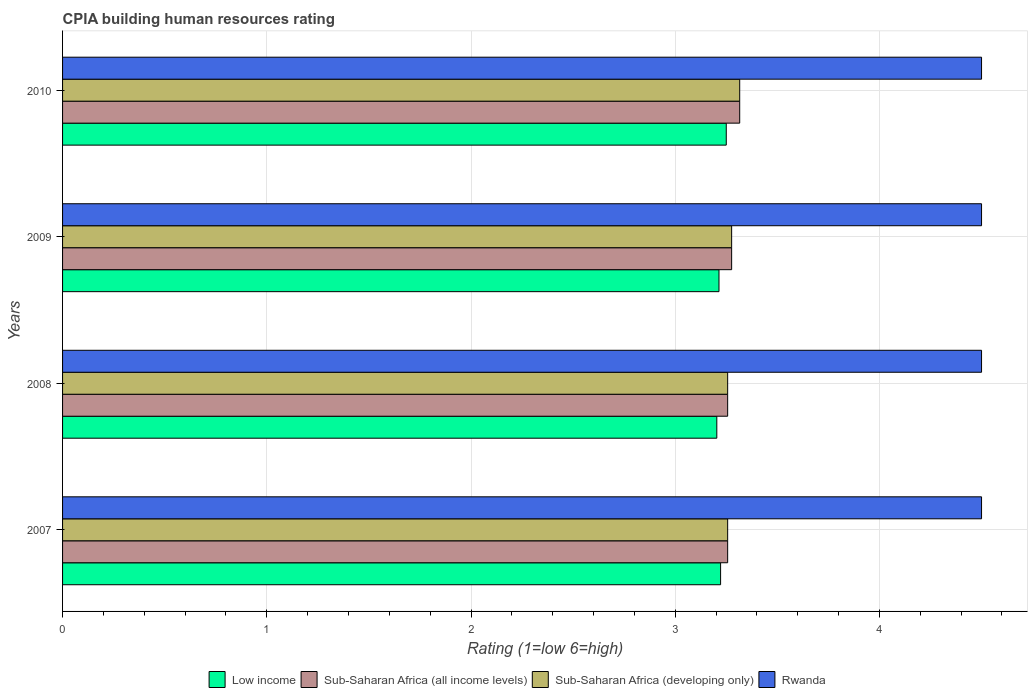How many different coloured bars are there?
Give a very brief answer. 4. How many groups of bars are there?
Offer a terse response. 4. Are the number of bars per tick equal to the number of legend labels?
Keep it short and to the point. Yes. Are the number of bars on each tick of the Y-axis equal?
Keep it short and to the point. Yes. How many bars are there on the 4th tick from the top?
Provide a succinct answer. 4. What is the CPIA rating in Sub-Saharan Africa (all income levels) in 2010?
Offer a very short reply. 3.32. Across all years, what is the minimum CPIA rating in Low income?
Ensure brevity in your answer.  3.2. In which year was the CPIA rating in Sub-Saharan Africa (all income levels) maximum?
Give a very brief answer. 2010. What is the total CPIA rating in Low income in the graph?
Make the answer very short. 12.89. What is the difference between the CPIA rating in Low income in 2008 and that in 2009?
Give a very brief answer. -0.01. What is the difference between the CPIA rating in Low income in 2009 and the CPIA rating in Sub-Saharan Africa (all income levels) in 2007?
Ensure brevity in your answer.  -0.04. What is the average CPIA rating in Low income per year?
Give a very brief answer. 3.22. In the year 2010, what is the difference between the CPIA rating in Sub-Saharan Africa (all income levels) and CPIA rating in Rwanda?
Give a very brief answer. -1.18. In how many years, is the CPIA rating in Low income greater than 3.8 ?
Your answer should be compact. 0. What is the ratio of the CPIA rating in Low income in 2007 to that in 2009?
Give a very brief answer. 1. Is the CPIA rating in Sub-Saharan Africa (developing only) in 2008 less than that in 2009?
Your response must be concise. Yes. What is the difference between the highest and the lowest CPIA rating in Low income?
Your answer should be compact. 0.05. Is the sum of the CPIA rating in Sub-Saharan Africa (all income levels) in 2009 and 2010 greater than the maximum CPIA rating in Low income across all years?
Make the answer very short. Yes. Is it the case that in every year, the sum of the CPIA rating in Rwanda and CPIA rating in Sub-Saharan Africa (developing only) is greater than the sum of CPIA rating in Sub-Saharan Africa (all income levels) and CPIA rating in Low income?
Give a very brief answer. No. What does the 1st bar from the top in 2008 represents?
Ensure brevity in your answer.  Rwanda. What does the 4th bar from the bottom in 2007 represents?
Make the answer very short. Rwanda. Is it the case that in every year, the sum of the CPIA rating in Rwanda and CPIA rating in Low income is greater than the CPIA rating in Sub-Saharan Africa (all income levels)?
Your answer should be very brief. Yes. How many bars are there?
Your answer should be compact. 16. Does the graph contain grids?
Your answer should be compact. Yes. Where does the legend appear in the graph?
Make the answer very short. Bottom center. How many legend labels are there?
Your answer should be very brief. 4. How are the legend labels stacked?
Your answer should be compact. Horizontal. What is the title of the graph?
Offer a very short reply. CPIA building human resources rating. Does "Bulgaria" appear as one of the legend labels in the graph?
Give a very brief answer. No. What is the label or title of the X-axis?
Offer a very short reply. Rating (1=low 6=high). What is the label or title of the Y-axis?
Provide a short and direct response. Years. What is the Rating (1=low 6=high) in Low income in 2007?
Give a very brief answer. 3.22. What is the Rating (1=low 6=high) in Sub-Saharan Africa (all income levels) in 2007?
Ensure brevity in your answer.  3.26. What is the Rating (1=low 6=high) in Sub-Saharan Africa (developing only) in 2007?
Your response must be concise. 3.26. What is the Rating (1=low 6=high) of Low income in 2008?
Offer a very short reply. 3.2. What is the Rating (1=low 6=high) in Sub-Saharan Africa (all income levels) in 2008?
Your response must be concise. 3.26. What is the Rating (1=low 6=high) in Sub-Saharan Africa (developing only) in 2008?
Keep it short and to the point. 3.26. What is the Rating (1=low 6=high) of Rwanda in 2008?
Make the answer very short. 4.5. What is the Rating (1=low 6=high) in Low income in 2009?
Provide a succinct answer. 3.21. What is the Rating (1=low 6=high) of Sub-Saharan Africa (all income levels) in 2009?
Your response must be concise. 3.28. What is the Rating (1=low 6=high) in Sub-Saharan Africa (developing only) in 2009?
Provide a succinct answer. 3.28. What is the Rating (1=low 6=high) of Rwanda in 2009?
Offer a terse response. 4.5. What is the Rating (1=low 6=high) of Low income in 2010?
Your response must be concise. 3.25. What is the Rating (1=low 6=high) in Sub-Saharan Africa (all income levels) in 2010?
Your response must be concise. 3.32. What is the Rating (1=low 6=high) in Sub-Saharan Africa (developing only) in 2010?
Your response must be concise. 3.32. What is the Rating (1=low 6=high) of Rwanda in 2010?
Provide a short and direct response. 4.5. Across all years, what is the maximum Rating (1=low 6=high) in Sub-Saharan Africa (all income levels)?
Provide a succinct answer. 3.32. Across all years, what is the maximum Rating (1=low 6=high) of Sub-Saharan Africa (developing only)?
Ensure brevity in your answer.  3.32. Across all years, what is the maximum Rating (1=low 6=high) of Rwanda?
Give a very brief answer. 4.5. Across all years, what is the minimum Rating (1=low 6=high) in Low income?
Provide a short and direct response. 3.2. Across all years, what is the minimum Rating (1=low 6=high) of Sub-Saharan Africa (all income levels)?
Offer a very short reply. 3.26. Across all years, what is the minimum Rating (1=low 6=high) of Sub-Saharan Africa (developing only)?
Your response must be concise. 3.26. What is the total Rating (1=low 6=high) in Low income in the graph?
Keep it short and to the point. 12.89. What is the total Rating (1=low 6=high) in Sub-Saharan Africa (all income levels) in the graph?
Provide a succinct answer. 13.11. What is the total Rating (1=low 6=high) of Sub-Saharan Africa (developing only) in the graph?
Provide a short and direct response. 13.11. What is the total Rating (1=low 6=high) of Rwanda in the graph?
Your response must be concise. 18. What is the difference between the Rating (1=low 6=high) of Low income in 2007 and that in 2008?
Your answer should be compact. 0.02. What is the difference between the Rating (1=low 6=high) of Rwanda in 2007 and that in 2008?
Offer a terse response. 0. What is the difference between the Rating (1=low 6=high) of Low income in 2007 and that in 2009?
Your answer should be compact. 0.01. What is the difference between the Rating (1=low 6=high) of Sub-Saharan Africa (all income levels) in 2007 and that in 2009?
Your response must be concise. -0.02. What is the difference between the Rating (1=low 6=high) in Sub-Saharan Africa (developing only) in 2007 and that in 2009?
Your answer should be compact. -0.02. What is the difference between the Rating (1=low 6=high) of Rwanda in 2007 and that in 2009?
Ensure brevity in your answer.  0. What is the difference between the Rating (1=low 6=high) of Low income in 2007 and that in 2010?
Give a very brief answer. -0.03. What is the difference between the Rating (1=low 6=high) in Sub-Saharan Africa (all income levels) in 2007 and that in 2010?
Provide a succinct answer. -0.06. What is the difference between the Rating (1=low 6=high) of Sub-Saharan Africa (developing only) in 2007 and that in 2010?
Your answer should be very brief. -0.06. What is the difference between the Rating (1=low 6=high) in Low income in 2008 and that in 2009?
Offer a terse response. -0.01. What is the difference between the Rating (1=low 6=high) of Sub-Saharan Africa (all income levels) in 2008 and that in 2009?
Provide a succinct answer. -0.02. What is the difference between the Rating (1=low 6=high) of Sub-Saharan Africa (developing only) in 2008 and that in 2009?
Offer a terse response. -0.02. What is the difference between the Rating (1=low 6=high) in Rwanda in 2008 and that in 2009?
Provide a succinct answer. 0. What is the difference between the Rating (1=low 6=high) of Low income in 2008 and that in 2010?
Offer a very short reply. -0.05. What is the difference between the Rating (1=low 6=high) of Sub-Saharan Africa (all income levels) in 2008 and that in 2010?
Provide a succinct answer. -0.06. What is the difference between the Rating (1=low 6=high) in Sub-Saharan Africa (developing only) in 2008 and that in 2010?
Provide a short and direct response. -0.06. What is the difference between the Rating (1=low 6=high) in Low income in 2009 and that in 2010?
Your answer should be compact. -0.04. What is the difference between the Rating (1=low 6=high) in Sub-Saharan Africa (all income levels) in 2009 and that in 2010?
Your answer should be very brief. -0.04. What is the difference between the Rating (1=low 6=high) of Sub-Saharan Africa (developing only) in 2009 and that in 2010?
Offer a very short reply. -0.04. What is the difference between the Rating (1=low 6=high) of Low income in 2007 and the Rating (1=low 6=high) of Sub-Saharan Africa (all income levels) in 2008?
Your answer should be compact. -0.03. What is the difference between the Rating (1=low 6=high) of Low income in 2007 and the Rating (1=low 6=high) of Sub-Saharan Africa (developing only) in 2008?
Ensure brevity in your answer.  -0.03. What is the difference between the Rating (1=low 6=high) of Low income in 2007 and the Rating (1=low 6=high) of Rwanda in 2008?
Give a very brief answer. -1.28. What is the difference between the Rating (1=low 6=high) in Sub-Saharan Africa (all income levels) in 2007 and the Rating (1=low 6=high) in Rwanda in 2008?
Give a very brief answer. -1.24. What is the difference between the Rating (1=low 6=high) of Sub-Saharan Africa (developing only) in 2007 and the Rating (1=low 6=high) of Rwanda in 2008?
Keep it short and to the point. -1.24. What is the difference between the Rating (1=low 6=high) in Low income in 2007 and the Rating (1=low 6=high) in Sub-Saharan Africa (all income levels) in 2009?
Your response must be concise. -0.05. What is the difference between the Rating (1=low 6=high) of Low income in 2007 and the Rating (1=low 6=high) of Sub-Saharan Africa (developing only) in 2009?
Provide a short and direct response. -0.05. What is the difference between the Rating (1=low 6=high) in Low income in 2007 and the Rating (1=low 6=high) in Rwanda in 2009?
Your answer should be very brief. -1.28. What is the difference between the Rating (1=low 6=high) in Sub-Saharan Africa (all income levels) in 2007 and the Rating (1=low 6=high) in Sub-Saharan Africa (developing only) in 2009?
Give a very brief answer. -0.02. What is the difference between the Rating (1=low 6=high) of Sub-Saharan Africa (all income levels) in 2007 and the Rating (1=low 6=high) of Rwanda in 2009?
Provide a short and direct response. -1.24. What is the difference between the Rating (1=low 6=high) in Sub-Saharan Africa (developing only) in 2007 and the Rating (1=low 6=high) in Rwanda in 2009?
Offer a very short reply. -1.24. What is the difference between the Rating (1=low 6=high) in Low income in 2007 and the Rating (1=low 6=high) in Sub-Saharan Africa (all income levels) in 2010?
Keep it short and to the point. -0.09. What is the difference between the Rating (1=low 6=high) in Low income in 2007 and the Rating (1=low 6=high) in Sub-Saharan Africa (developing only) in 2010?
Offer a terse response. -0.09. What is the difference between the Rating (1=low 6=high) in Low income in 2007 and the Rating (1=low 6=high) in Rwanda in 2010?
Your response must be concise. -1.28. What is the difference between the Rating (1=low 6=high) of Sub-Saharan Africa (all income levels) in 2007 and the Rating (1=low 6=high) of Sub-Saharan Africa (developing only) in 2010?
Make the answer very short. -0.06. What is the difference between the Rating (1=low 6=high) of Sub-Saharan Africa (all income levels) in 2007 and the Rating (1=low 6=high) of Rwanda in 2010?
Your answer should be very brief. -1.24. What is the difference between the Rating (1=low 6=high) of Sub-Saharan Africa (developing only) in 2007 and the Rating (1=low 6=high) of Rwanda in 2010?
Keep it short and to the point. -1.24. What is the difference between the Rating (1=low 6=high) in Low income in 2008 and the Rating (1=low 6=high) in Sub-Saharan Africa (all income levels) in 2009?
Offer a terse response. -0.07. What is the difference between the Rating (1=low 6=high) of Low income in 2008 and the Rating (1=low 6=high) of Sub-Saharan Africa (developing only) in 2009?
Your response must be concise. -0.07. What is the difference between the Rating (1=low 6=high) of Low income in 2008 and the Rating (1=low 6=high) of Rwanda in 2009?
Offer a terse response. -1.3. What is the difference between the Rating (1=low 6=high) of Sub-Saharan Africa (all income levels) in 2008 and the Rating (1=low 6=high) of Sub-Saharan Africa (developing only) in 2009?
Keep it short and to the point. -0.02. What is the difference between the Rating (1=low 6=high) of Sub-Saharan Africa (all income levels) in 2008 and the Rating (1=low 6=high) of Rwanda in 2009?
Your answer should be compact. -1.24. What is the difference between the Rating (1=low 6=high) in Sub-Saharan Africa (developing only) in 2008 and the Rating (1=low 6=high) in Rwanda in 2009?
Your answer should be compact. -1.24. What is the difference between the Rating (1=low 6=high) of Low income in 2008 and the Rating (1=low 6=high) of Sub-Saharan Africa (all income levels) in 2010?
Give a very brief answer. -0.11. What is the difference between the Rating (1=low 6=high) in Low income in 2008 and the Rating (1=low 6=high) in Sub-Saharan Africa (developing only) in 2010?
Your answer should be compact. -0.11. What is the difference between the Rating (1=low 6=high) in Low income in 2008 and the Rating (1=low 6=high) in Rwanda in 2010?
Provide a short and direct response. -1.3. What is the difference between the Rating (1=low 6=high) in Sub-Saharan Africa (all income levels) in 2008 and the Rating (1=low 6=high) in Sub-Saharan Africa (developing only) in 2010?
Ensure brevity in your answer.  -0.06. What is the difference between the Rating (1=low 6=high) of Sub-Saharan Africa (all income levels) in 2008 and the Rating (1=low 6=high) of Rwanda in 2010?
Provide a short and direct response. -1.24. What is the difference between the Rating (1=low 6=high) in Sub-Saharan Africa (developing only) in 2008 and the Rating (1=low 6=high) in Rwanda in 2010?
Offer a very short reply. -1.24. What is the difference between the Rating (1=low 6=high) in Low income in 2009 and the Rating (1=low 6=high) in Sub-Saharan Africa (all income levels) in 2010?
Make the answer very short. -0.1. What is the difference between the Rating (1=low 6=high) of Low income in 2009 and the Rating (1=low 6=high) of Sub-Saharan Africa (developing only) in 2010?
Offer a very short reply. -0.1. What is the difference between the Rating (1=low 6=high) of Low income in 2009 and the Rating (1=low 6=high) of Rwanda in 2010?
Provide a succinct answer. -1.29. What is the difference between the Rating (1=low 6=high) of Sub-Saharan Africa (all income levels) in 2009 and the Rating (1=low 6=high) of Sub-Saharan Africa (developing only) in 2010?
Give a very brief answer. -0.04. What is the difference between the Rating (1=low 6=high) in Sub-Saharan Africa (all income levels) in 2009 and the Rating (1=low 6=high) in Rwanda in 2010?
Ensure brevity in your answer.  -1.22. What is the difference between the Rating (1=low 6=high) in Sub-Saharan Africa (developing only) in 2009 and the Rating (1=low 6=high) in Rwanda in 2010?
Your answer should be very brief. -1.22. What is the average Rating (1=low 6=high) in Low income per year?
Your answer should be compact. 3.22. What is the average Rating (1=low 6=high) of Sub-Saharan Africa (all income levels) per year?
Your answer should be compact. 3.28. What is the average Rating (1=low 6=high) of Sub-Saharan Africa (developing only) per year?
Provide a short and direct response. 3.28. What is the average Rating (1=low 6=high) in Rwanda per year?
Ensure brevity in your answer.  4.5. In the year 2007, what is the difference between the Rating (1=low 6=high) of Low income and Rating (1=low 6=high) of Sub-Saharan Africa (all income levels)?
Ensure brevity in your answer.  -0.03. In the year 2007, what is the difference between the Rating (1=low 6=high) in Low income and Rating (1=low 6=high) in Sub-Saharan Africa (developing only)?
Offer a terse response. -0.03. In the year 2007, what is the difference between the Rating (1=low 6=high) in Low income and Rating (1=low 6=high) in Rwanda?
Your answer should be compact. -1.28. In the year 2007, what is the difference between the Rating (1=low 6=high) of Sub-Saharan Africa (all income levels) and Rating (1=low 6=high) of Rwanda?
Ensure brevity in your answer.  -1.24. In the year 2007, what is the difference between the Rating (1=low 6=high) in Sub-Saharan Africa (developing only) and Rating (1=low 6=high) in Rwanda?
Your answer should be very brief. -1.24. In the year 2008, what is the difference between the Rating (1=low 6=high) of Low income and Rating (1=low 6=high) of Sub-Saharan Africa (all income levels)?
Provide a succinct answer. -0.05. In the year 2008, what is the difference between the Rating (1=low 6=high) in Low income and Rating (1=low 6=high) in Sub-Saharan Africa (developing only)?
Provide a succinct answer. -0.05. In the year 2008, what is the difference between the Rating (1=low 6=high) in Low income and Rating (1=low 6=high) in Rwanda?
Keep it short and to the point. -1.3. In the year 2008, what is the difference between the Rating (1=low 6=high) in Sub-Saharan Africa (all income levels) and Rating (1=low 6=high) in Rwanda?
Keep it short and to the point. -1.24. In the year 2008, what is the difference between the Rating (1=low 6=high) in Sub-Saharan Africa (developing only) and Rating (1=low 6=high) in Rwanda?
Your answer should be compact. -1.24. In the year 2009, what is the difference between the Rating (1=low 6=high) in Low income and Rating (1=low 6=high) in Sub-Saharan Africa (all income levels)?
Provide a succinct answer. -0.06. In the year 2009, what is the difference between the Rating (1=low 6=high) in Low income and Rating (1=low 6=high) in Sub-Saharan Africa (developing only)?
Offer a very short reply. -0.06. In the year 2009, what is the difference between the Rating (1=low 6=high) of Low income and Rating (1=low 6=high) of Rwanda?
Your answer should be compact. -1.29. In the year 2009, what is the difference between the Rating (1=low 6=high) of Sub-Saharan Africa (all income levels) and Rating (1=low 6=high) of Rwanda?
Your answer should be very brief. -1.22. In the year 2009, what is the difference between the Rating (1=low 6=high) of Sub-Saharan Africa (developing only) and Rating (1=low 6=high) of Rwanda?
Your response must be concise. -1.22. In the year 2010, what is the difference between the Rating (1=low 6=high) of Low income and Rating (1=low 6=high) of Sub-Saharan Africa (all income levels)?
Provide a succinct answer. -0.07. In the year 2010, what is the difference between the Rating (1=low 6=high) of Low income and Rating (1=low 6=high) of Sub-Saharan Africa (developing only)?
Keep it short and to the point. -0.07. In the year 2010, what is the difference between the Rating (1=low 6=high) in Low income and Rating (1=low 6=high) in Rwanda?
Provide a succinct answer. -1.25. In the year 2010, what is the difference between the Rating (1=low 6=high) in Sub-Saharan Africa (all income levels) and Rating (1=low 6=high) in Rwanda?
Your answer should be compact. -1.18. In the year 2010, what is the difference between the Rating (1=low 6=high) in Sub-Saharan Africa (developing only) and Rating (1=low 6=high) in Rwanda?
Your response must be concise. -1.18. What is the ratio of the Rating (1=low 6=high) in Sub-Saharan Africa (all income levels) in 2007 to that in 2008?
Keep it short and to the point. 1. What is the ratio of the Rating (1=low 6=high) in Sub-Saharan Africa (developing only) in 2007 to that in 2008?
Offer a terse response. 1. What is the ratio of the Rating (1=low 6=high) in Sub-Saharan Africa (all income levels) in 2007 to that in 2009?
Provide a succinct answer. 0.99. What is the ratio of the Rating (1=low 6=high) in Sub-Saharan Africa (all income levels) in 2007 to that in 2010?
Make the answer very short. 0.98. What is the ratio of the Rating (1=low 6=high) of Sub-Saharan Africa (developing only) in 2007 to that in 2010?
Provide a succinct answer. 0.98. What is the ratio of the Rating (1=low 6=high) in Sub-Saharan Africa (all income levels) in 2008 to that in 2009?
Your answer should be compact. 0.99. What is the ratio of the Rating (1=low 6=high) in Sub-Saharan Africa (developing only) in 2008 to that in 2009?
Offer a very short reply. 0.99. What is the ratio of the Rating (1=low 6=high) in Low income in 2008 to that in 2010?
Give a very brief answer. 0.99. What is the ratio of the Rating (1=low 6=high) of Sub-Saharan Africa (all income levels) in 2008 to that in 2010?
Your response must be concise. 0.98. What is the ratio of the Rating (1=low 6=high) in Sub-Saharan Africa (developing only) in 2008 to that in 2010?
Offer a terse response. 0.98. What is the ratio of the Rating (1=low 6=high) of Rwanda in 2008 to that in 2010?
Give a very brief answer. 1. What is the ratio of the Rating (1=low 6=high) of Sub-Saharan Africa (all income levels) in 2009 to that in 2010?
Keep it short and to the point. 0.99. What is the ratio of the Rating (1=low 6=high) in Sub-Saharan Africa (developing only) in 2009 to that in 2010?
Provide a short and direct response. 0.99. What is the ratio of the Rating (1=low 6=high) of Rwanda in 2009 to that in 2010?
Provide a succinct answer. 1. What is the difference between the highest and the second highest Rating (1=low 6=high) of Low income?
Your answer should be very brief. 0.03. What is the difference between the highest and the second highest Rating (1=low 6=high) of Sub-Saharan Africa (all income levels)?
Your answer should be very brief. 0.04. What is the difference between the highest and the second highest Rating (1=low 6=high) of Sub-Saharan Africa (developing only)?
Make the answer very short. 0.04. What is the difference between the highest and the lowest Rating (1=low 6=high) in Low income?
Ensure brevity in your answer.  0.05. What is the difference between the highest and the lowest Rating (1=low 6=high) in Sub-Saharan Africa (all income levels)?
Offer a very short reply. 0.06. What is the difference between the highest and the lowest Rating (1=low 6=high) of Sub-Saharan Africa (developing only)?
Give a very brief answer. 0.06. What is the difference between the highest and the lowest Rating (1=low 6=high) of Rwanda?
Your answer should be very brief. 0. 